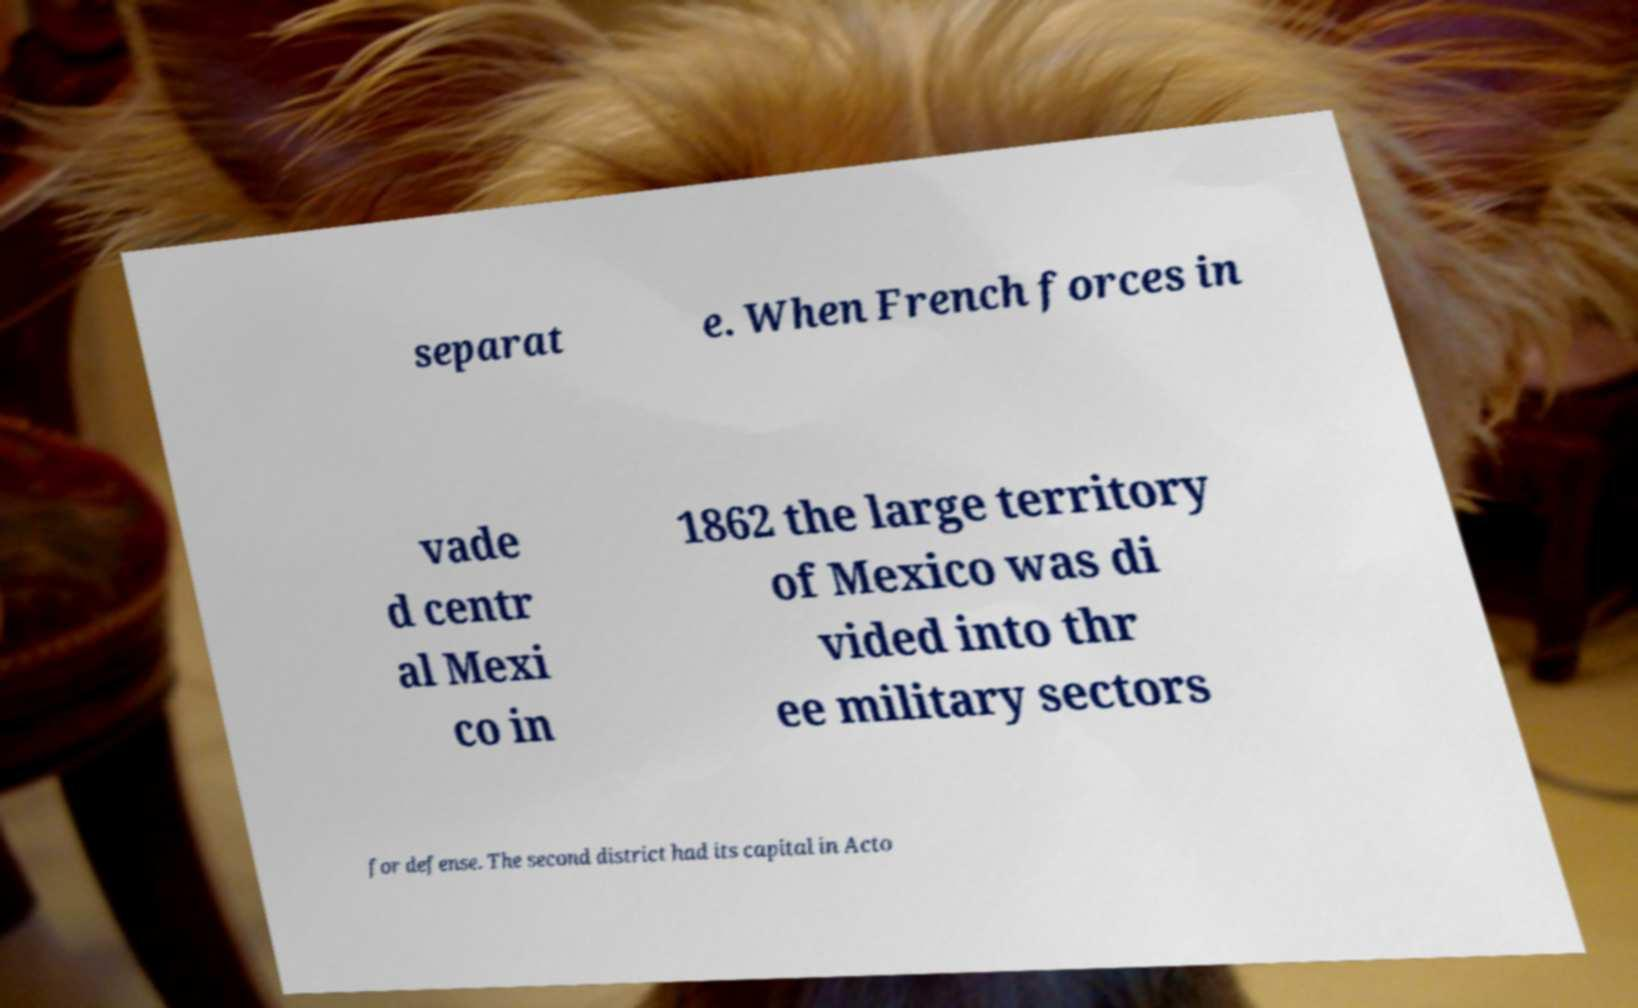Can you read and provide the text displayed in the image?This photo seems to have some interesting text. Can you extract and type it out for me? separat e. When French forces in vade d centr al Mexi co in 1862 the large territory of Mexico was di vided into thr ee military sectors for defense. The second district had its capital in Acto 